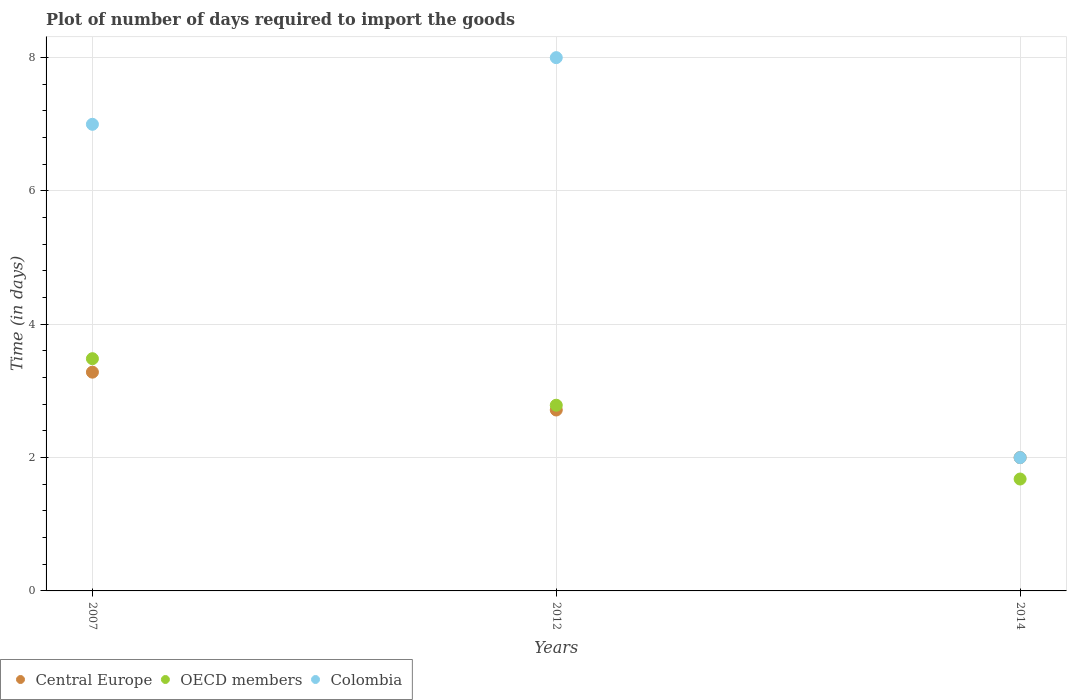How many different coloured dotlines are there?
Offer a terse response. 3. What is the time required to import goods in Central Europe in 2012?
Keep it short and to the point. 2.71. Across all years, what is the maximum time required to import goods in OECD members?
Ensure brevity in your answer.  3.48. What is the total time required to import goods in Central Europe in the graph?
Provide a succinct answer. 8. What is the difference between the time required to import goods in Central Europe in 2007 and that in 2012?
Ensure brevity in your answer.  0.57. What is the difference between the time required to import goods in Colombia in 2007 and the time required to import goods in Central Europe in 2012?
Ensure brevity in your answer.  4.29. What is the average time required to import goods in OECD members per year?
Keep it short and to the point. 2.65. In the year 2012, what is the difference between the time required to import goods in OECD members and time required to import goods in Central Europe?
Ensure brevity in your answer.  0.07. What is the ratio of the time required to import goods in Colombia in 2007 to that in 2012?
Keep it short and to the point. 0.88. Is the time required to import goods in Colombia in 2012 less than that in 2014?
Ensure brevity in your answer.  No. Is the difference between the time required to import goods in OECD members in 2007 and 2014 greater than the difference between the time required to import goods in Central Europe in 2007 and 2014?
Provide a short and direct response. Yes. What is the difference between the highest and the second highest time required to import goods in Central Europe?
Provide a short and direct response. 0.57. What is the difference between the highest and the lowest time required to import goods in Central Europe?
Give a very brief answer. 1.28. In how many years, is the time required to import goods in OECD members greater than the average time required to import goods in OECD members taken over all years?
Offer a very short reply. 2. Is the sum of the time required to import goods in Colombia in 2007 and 2012 greater than the maximum time required to import goods in Central Europe across all years?
Your response must be concise. Yes. Does the time required to import goods in Colombia monotonically increase over the years?
Offer a terse response. No. Are the values on the major ticks of Y-axis written in scientific E-notation?
Provide a short and direct response. No. Does the graph contain any zero values?
Your answer should be very brief. No. Does the graph contain grids?
Offer a very short reply. Yes. How are the legend labels stacked?
Offer a terse response. Horizontal. What is the title of the graph?
Your response must be concise. Plot of number of days required to import the goods. What is the label or title of the Y-axis?
Your answer should be very brief. Time (in days). What is the Time (in days) in Central Europe in 2007?
Your response must be concise. 3.28. What is the Time (in days) in OECD members in 2007?
Provide a short and direct response. 3.48. What is the Time (in days) of Central Europe in 2012?
Make the answer very short. 2.71. What is the Time (in days) in OECD members in 2012?
Make the answer very short. 2.79. What is the Time (in days) in Colombia in 2012?
Keep it short and to the point. 8. What is the Time (in days) in Central Europe in 2014?
Your response must be concise. 2. What is the Time (in days) of OECD members in 2014?
Your response must be concise. 1.68. What is the Time (in days) in Colombia in 2014?
Offer a very short reply. 2. Across all years, what is the maximum Time (in days) of Central Europe?
Provide a short and direct response. 3.28. Across all years, what is the maximum Time (in days) in OECD members?
Give a very brief answer. 3.48. Across all years, what is the maximum Time (in days) in Colombia?
Your answer should be compact. 8. Across all years, what is the minimum Time (in days) of Central Europe?
Ensure brevity in your answer.  2. Across all years, what is the minimum Time (in days) of OECD members?
Provide a succinct answer. 1.68. Across all years, what is the minimum Time (in days) of Colombia?
Your answer should be very brief. 2. What is the total Time (in days) of Central Europe in the graph?
Your answer should be very brief. 8. What is the total Time (in days) in OECD members in the graph?
Ensure brevity in your answer.  7.95. What is the difference between the Time (in days) of Central Europe in 2007 and that in 2012?
Make the answer very short. 0.57. What is the difference between the Time (in days) in OECD members in 2007 and that in 2012?
Ensure brevity in your answer.  0.7. What is the difference between the Time (in days) of Colombia in 2007 and that in 2012?
Your answer should be very brief. -1. What is the difference between the Time (in days) in Central Europe in 2007 and that in 2014?
Provide a short and direct response. 1.28. What is the difference between the Time (in days) of OECD members in 2007 and that in 2014?
Offer a terse response. 1.81. What is the difference between the Time (in days) of OECD members in 2012 and that in 2014?
Offer a terse response. 1.11. What is the difference between the Time (in days) in Central Europe in 2007 and the Time (in days) in OECD members in 2012?
Make the answer very short. 0.5. What is the difference between the Time (in days) in Central Europe in 2007 and the Time (in days) in Colombia in 2012?
Give a very brief answer. -4.72. What is the difference between the Time (in days) in OECD members in 2007 and the Time (in days) in Colombia in 2012?
Make the answer very short. -4.52. What is the difference between the Time (in days) in Central Europe in 2007 and the Time (in days) in OECD members in 2014?
Your answer should be compact. 1.6. What is the difference between the Time (in days) in Central Europe in 2007 and the Time (in days) in Colombia in 2014?
Offer a very short reply. 1.28. What is the difference between the Time (in days) in OECD members in 2007 and the Time (in days) in Colombia in 2014?
Offer a terse response. 1.48. What is the difference between the Time (in days) of Central Europe in 2012 and the Time (in days) of OECD members in 2014?
Provide a succinct answer. 1.04. What is the difference between the Time (in days) in Central Europe in 2012 and the Time (in days) in Colombia in 2014?
Provide a succinct answer. 0.71. What is the difference between the Time (in days) of OECD members in 2012 and the Time (in days) of Colombia in 2014?
Provide a short and direct response. 0.79. What is the average Time (in days) in Central Europe per year?
Make the answer very short. 2.67. What is the average Time (in days) in OECD members per year?
Your answer should be compact. 2.65. What is the average Time (in days) in Colombia per year?
Provide a succinct answer. 5.67. In the year 2007, what is the difference between the Time (in days) in Central Europe and Time (in days) in OECD members?
Your answer should be very brief. -0.2. In the year 2007, what is the difference between the Time (in days) of Central Europe and Time (in days) of Colombia?
Keep it short and to the point. -3.72. In the year 2007, what is the difference between the Time (in days) of OECD members and Time (in days) of Colombia?
Give a very brief answer. -3.52. In the year 2012, what is the difference between the Time (in days) of Central Europe and Time (in days) of OECD members?
Provide a short and direct response. -0.07. In the year 2012, what is the difference between the Time (in days) of Central Europe and Time (in days) of Colombia?
Your answer should be very brief. -5.29. In the year 2012, what is the difference between the Time (in days) in OECD members and Time (in days) in Colombia?
Offer a very short reply. -5.21. In the year 2014, what is the difference between the Time (in days) of Central Europe and Time (in days) of OECD members?
Provide a short and direct response. 0.32. In the year 2014, what is the difference between the Time (in days) of OECD members and Time (in days) of Colombia?
Give a very brief answer. -0.32. What is the ratio of the Time (in days) in Central Europe in 2007 to that in 2012?
Offer a terse response. 1.21. What is the ratio of the Time (in days) of OECD members in 2007 to that in 2012?
Offer a terse response. 1.25. What is the ratio of the Time (in days) of Central Europe in 2007 to that in 2014?
Offer a very short reply. 1.64. What is the ratio of the Time (in days) of OECD members in 2007 to that in 2014?
Your answer should be very brief. 2.08. What is the ratio of the Time (in days) of Central Europe in 2012 to that in 2014?
Your response must be concise. 1.36. What is the ratio of the Time (in days) of OECD members in 2012 to that in 2014?
Your answer should be compact. 1.66. What is the difference between the highest and the second highest Time (in days) of Central Europe?
Your response must be concise. 0.57. What is the difference between the highest and the second highest Time (in days) in OECD members?
Ensure brevity in your answer.  0.7. What is the difference between the highest and the lowest Time (in days) in Central Europe?
Offer a terse response. 1.28. What is the difference between the highest and the lowest Time (in days) of OECD members?
Provide a succinct answer. 1.81. 